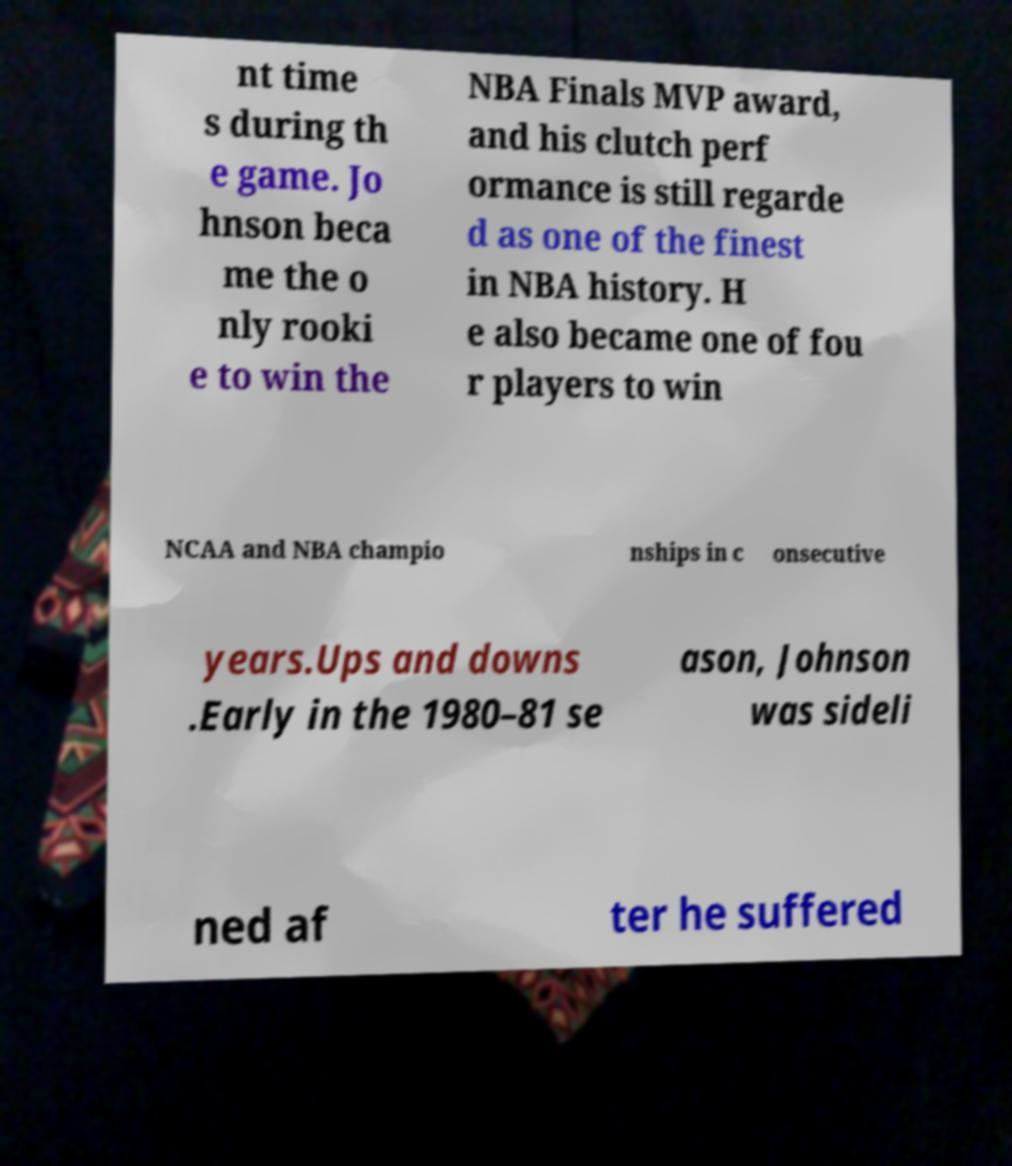What messages or text are displayed in this image? I need them in a readable, typed format. nt time s during th e game. Jo hnson beca me the o nly rooki e to win the NBA Finals MVP award, and his clutch perf ormance is still regarde d as one of the finest in NBA history. H e also became one of fou r players to win NCAA and NBA champio nships in c onsecutive years.Ups and downs .Early in the 1980–81 se ason, Johnson was sideli ned af ter he suffered 